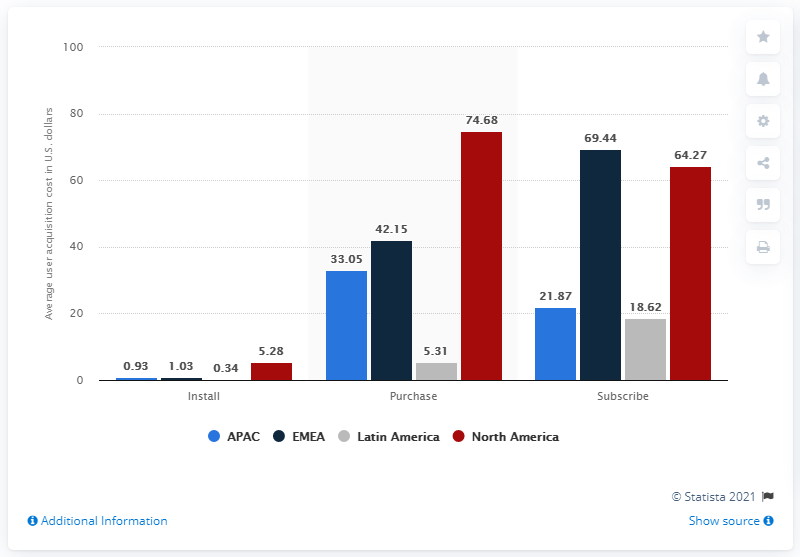Indicate a few pertinent items in this graphic. The cost to acquire an in-app buyer was approximately 74.68. The cost to get users to subscribe was approximately 64.27... 